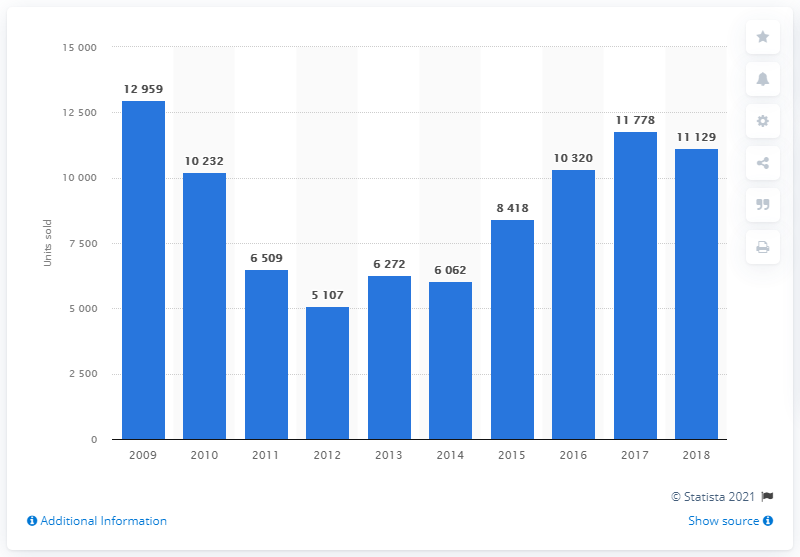Specify some key components in this picture. In 2012, a total of 5,107 Mazda cars were sold in France. 